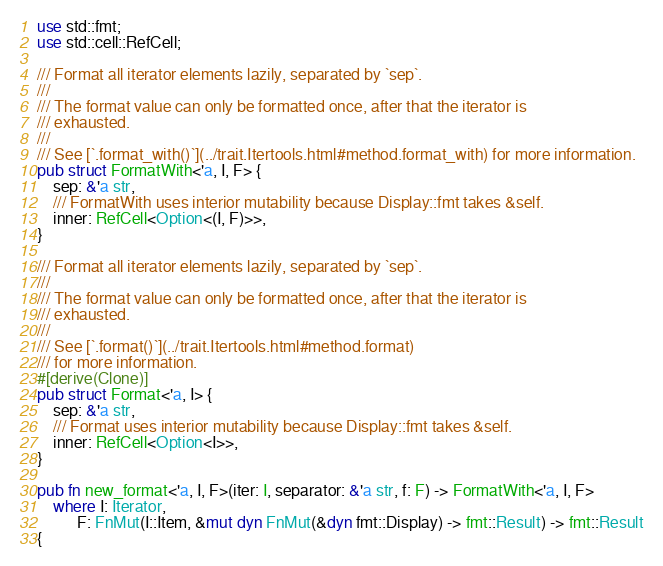Convert code to text. <code><loc_0><loc_0><loc_500><loc_500><_Rust_>use std::fmt;
use std::cell::RefCell;

/// Format all iterator elements lazily, separated by `sep`.
///
/// The format value can only be formatted once, after that the iterator is
/// exhausted.
///
/// See [`.format_with()`](../trait.Itertools.html#method.format_with) for more information.
pub struct FormatWith<'a, I, F> {
    sep: &'a str,
    /// FormatWith uses interior mutability because Display::fmt takes &self.
    inner: RefCell<Option<(I, F)>>,
}

/// Format all iterator elements lazily, separated by `sep`.
///
/// The format value can only be formatted once, after that the iterator is
/// exhausted.
///
/// See [`.format()`](../trait.Itertools.html#method.format)
/// for more information.
#[derive(Clone)]
pub struct Format<'a, I> {
    sep: &'a str,
    /// Format uses interior mutability because Display::fmt takes &self.
    inner: RefCell<Option<I>>,
}

pub fn new_format<'a, I, F>(iter: I, separator: &'a str, f: F) -> FormatWith<'a, I, F>
    where I: Iterator,
          F: FnMut(I::Item, &mut dyn FnMut(&dyn fmt::Display) -> fmt::Result) -> fmt::Result
{</code> 